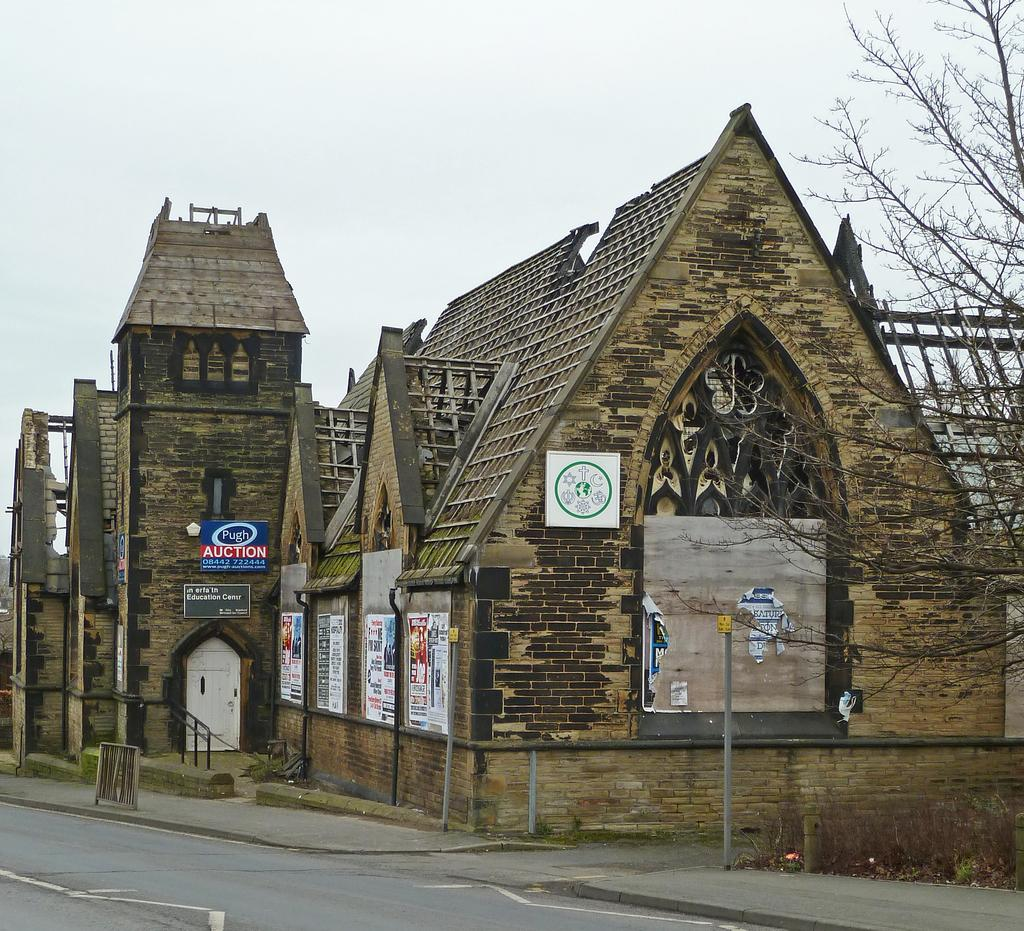What type of structure is in the picture? There is a brown shed house in the picture. What is in front of the shed house? There is a road in front of the shed house. What can be seen in the right corner of the image? There is a dry tree in the right corner of the image. What is visible at the top of the image? The sky is visible at the top of the image. What direction is the oil flowing in the image? A: There is no oil present in the image, so it cannot be determined if it is flowing or in which direction. 